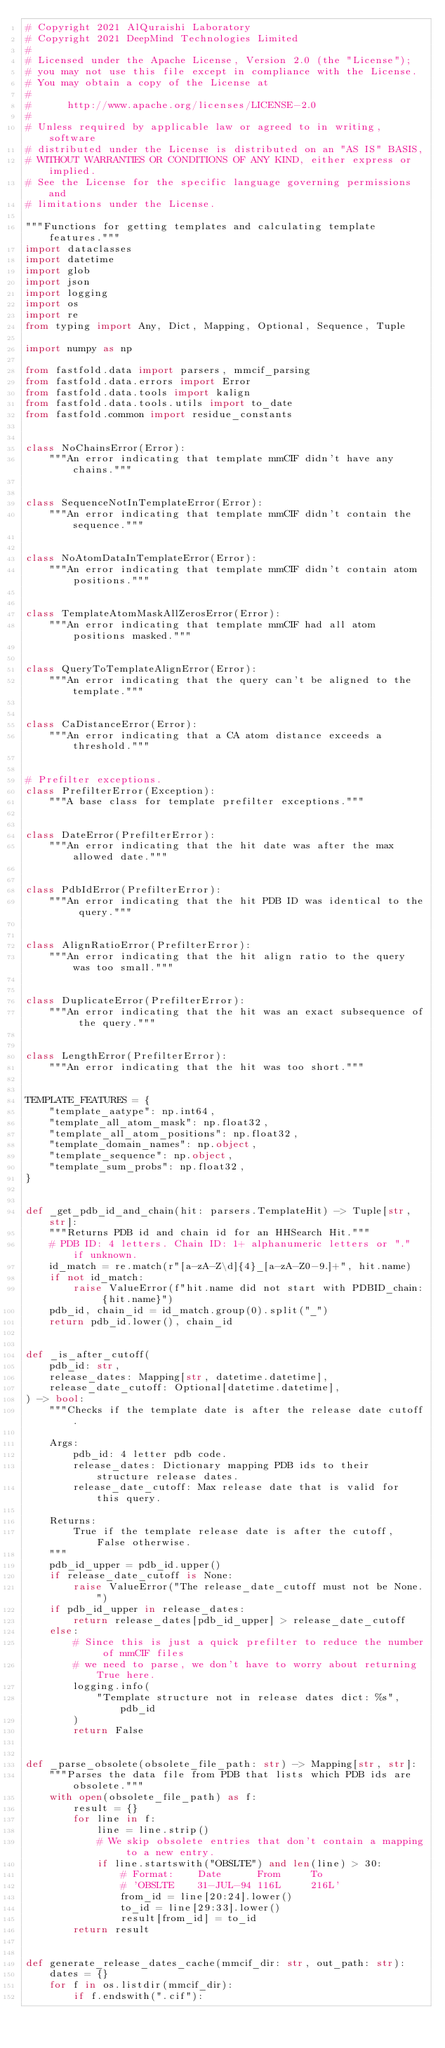Convert code to text. <code><loc_0><loc_0><loc_500><loc_500><_Python_># Copyright 2021 AlQuraishi Laboratory
# Copyright 2021 DeepMind Technologies Limited
#
# Licensed under the Apache License, Version 2.0 (the "License");
# you may not use this file except in compliance with the License.
# You may obtain a copy of the License at
#
#      http://www.apache.org/licenses/LICENSE-2.0
#
# Unless required by applicable law or agreed to in writing, software
# distributed under the License is distributed on an "AS IS" BASIS,
# WITHOUT WARRANTIES OR CONDITIONS OF ANY KIND, either express or implied.
# See the License for the specific language governing permissions and
# limitations under the License.

"""Functions for getting templates and calculating template features."""
import dataclasses
import datetime
import glob
import json
import logging
import os
import re
from typing import Any, Dict, Mapping, Optional, Sequence, Tuple

import numpy as np

from fastfold.data import parsers, mmcif_parsing
from fastfold.data.errors import Error
from fastfold.data.tools import kalign
from fastfold.data.tools.utils import to_date
from fastfold.common import residue_constants


class NoChainsError(Error):
    """An error indicating that template mmCIF didn't have any chains."""


class SequenceNotInTemplateError(Error):
    """An error indicating that template mmCIF didn't contain the sequence."""


class NoAtomDataInTemplateError(Error):
    """An error indicating that template mmCIF didn't contain atom positions."""


class TemplateAtomMaskAllZerosError(Error):
    """An error indicating that template mmCIF had all atom positions masked."""


class QueryToTemplateAlignError(Error):
    """An error indicating that the query can't be aligned to the template."""


class CaDistanceError(Error):
    """An error indicating that a CA atom distance exceeds a threshold."""


# Prefilter exceptions.
class PrefilterError(Exception):
    """A base class for template prefilter exceptions."""


class DateError(PrefilterError):
    """An error indicating that the hit date was after the max allowed date."""


class PdbIdError(PrefilterError):
    """An error indicating that the hit PDB ID was identical to the query."""


class AlignRatioError(PrefilterError):
    """An error indicating that the hit align ratio to the query was too small."""


class DuplicateError(PrefilterError):
    """An error indicating that the hit was an exact subsequence of the query."""


class LengthError(PrefilterError):
    """An error indicating that the hit was too short."""


TEMPLATE_FEATURES = {
    "template_aatype": np.int64,
    "template_all_atom_mask": np.float32,
    "template_all_atom_positions": np.float32,
    "template_domain_names": np.object,
    "template_sequence": np.object,
    "template_sum_probs": np.float32,
}


def _get_pdb_id_and_chain(hit: parsers.TemplateHit) -> Tuple[str, str]:
    """Returns PDB id and chain id for an HHSearch Hit."""
    # PDB ID: 4 letters. Chain ID: 1+ alphanumeric letters or "." if unknown.
    id_match = re.match(r"[a-zA-Z\d]{4}_[a-zA-Z0-9.]+", hit.name)
    if not id_match:
        raise ValueError(f"hit.name did not start with PDBID_chain: {hit.name}")
    pdb_id, chain_id = id_match.group(0).split("_")
    return pdb_id.lower(), chain_id


def _is_after_cutoff(
    pdb_id: str,
    release_dates: Mapping[str, datetime.datetime],
    release_date_cutoff: Optional[datetime.datetime],
) -> bool:
    """Checks if the template date is after the release date cutoff.

    Args:
        pdb_id: 4 letter pdb code.
        release_dates: Dictionary mapping PDB ids to their structure release dates.
        release_date_cutoff: Max release date that is valid for this query.

    Returns:
        True if the template release date is after the cutoff, False otherwise.
    """
    pdb_id_upper = pdb_id.upper()
    if release_date_cutoff is None:
        raise ValueError("The release_date_cutoff must not be None.")
    if pdb_id_upper in release_dates:
        return release_dates[pdb_id_upper] > release_date_cutoff
    else:
        # Since this is just a quick prefilter to reduce the number of mmCIF files
        # we need to parse, we don't have to worry about returning True here.
        logging.info(
            "Template structure not in release dates dict: %s", pdb_id
        )
        return False


def _parse_obsolete(obsolete_file_path: str) -> Mapping[str, str]:
    """Parses the data file from PDB that lists which PDB ids are obsolete."""
    with open(obsolete_file_path) as f:
        result = {}
        for line in f:
            line = line.strip()
            # We skip obsolete entries that don't contain a mapping to a new entry.
            if line.startswith("OBSLTE") and len(line) > 30:
                # Format:    Date      From     To
                # 'OBSLTE    31-JUL-94 116L     216L'
                from_id = line[20:24].lower()
                to_id = line[29:33].lower()
                result[from_id] = to_id
        return result


def generate_release_dates_cache(mmcif_dir: str, out_path: str):
    dates = {}
    for f in os.listdir(mmcif_dir):
        if f.endswith(".cif"):</code> 